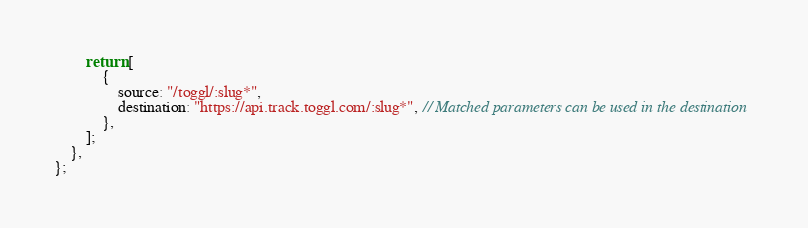Convert code to text. <code><loc_0><loc_0><loc_500><loc_500><_JavaScript_>		return [
			{
				source: "/toggl/:slug*",
				destination: "https://api.track.toggl.com/:slug*", // Matched parameters can be used in the destination
			},
		];
	},
};
</code> 